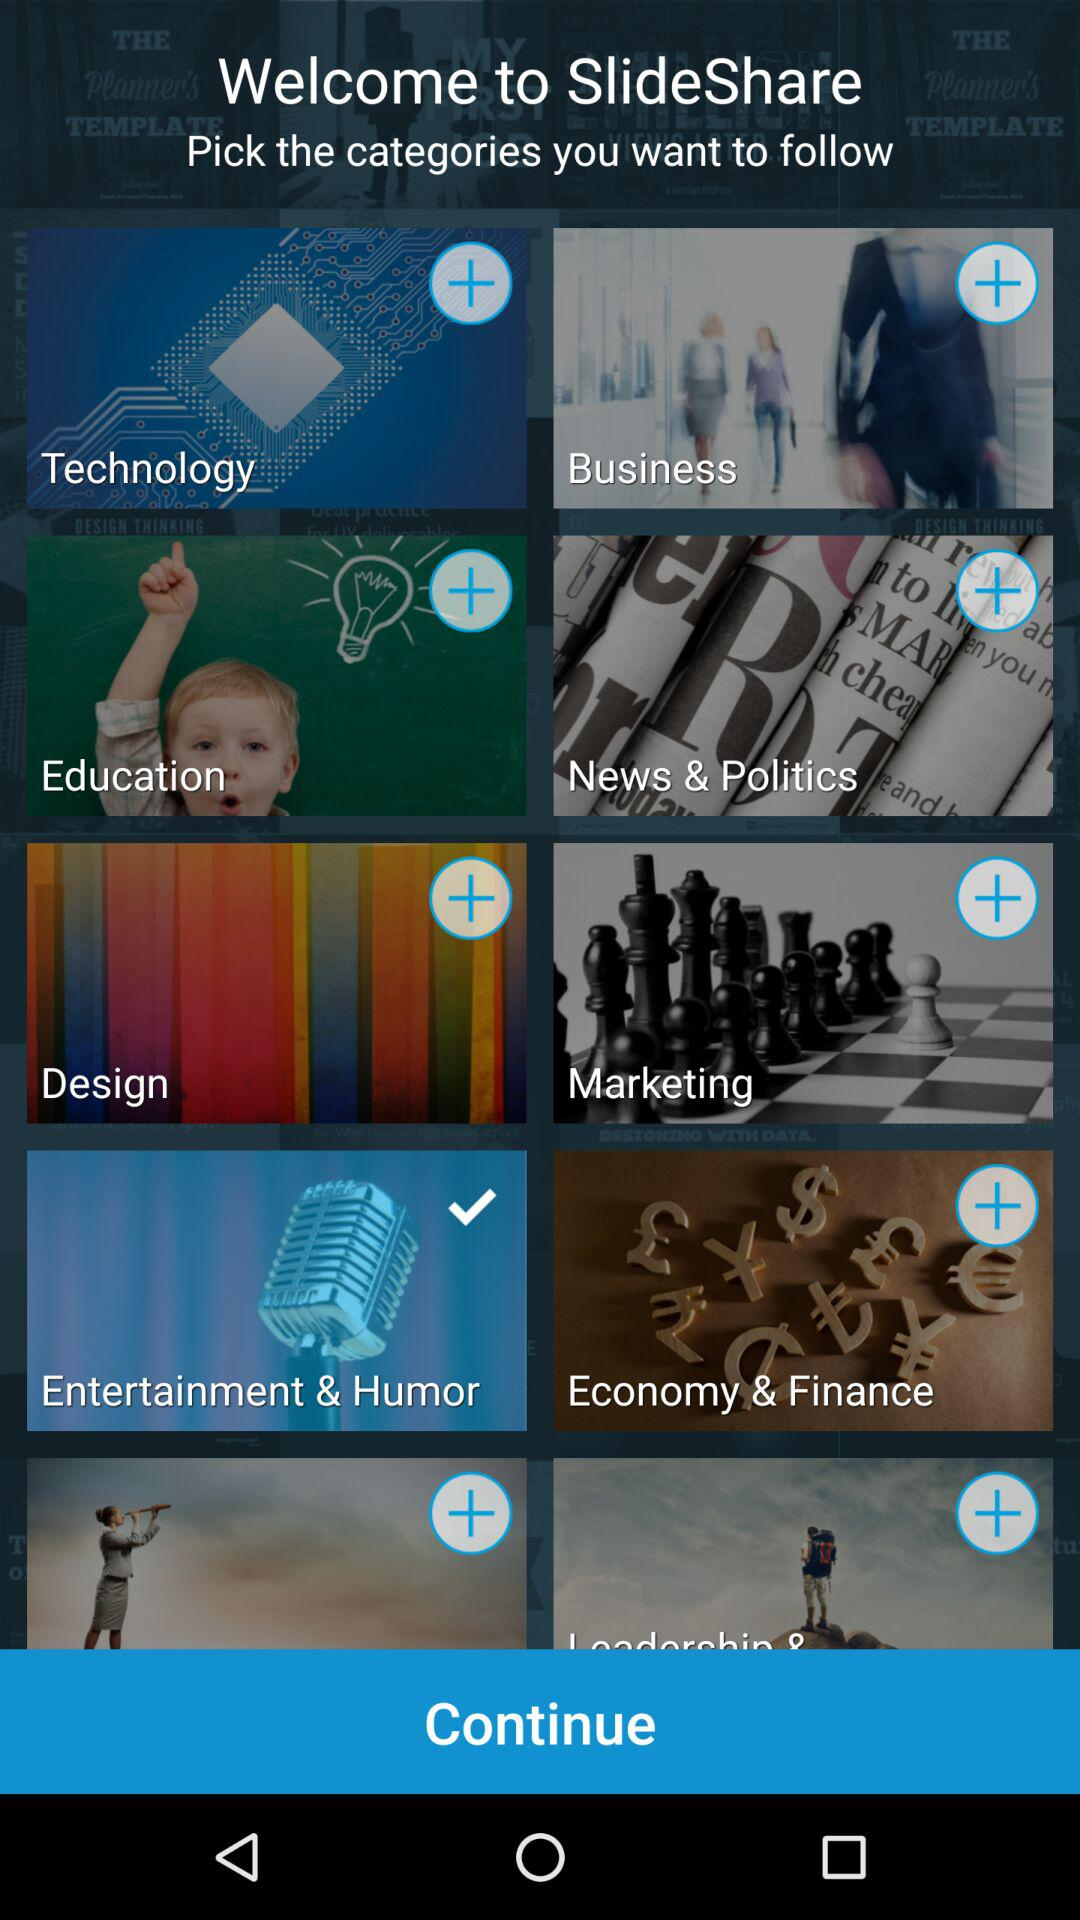Which categories are selected there? The selected category is "Entertainment & Humor". 